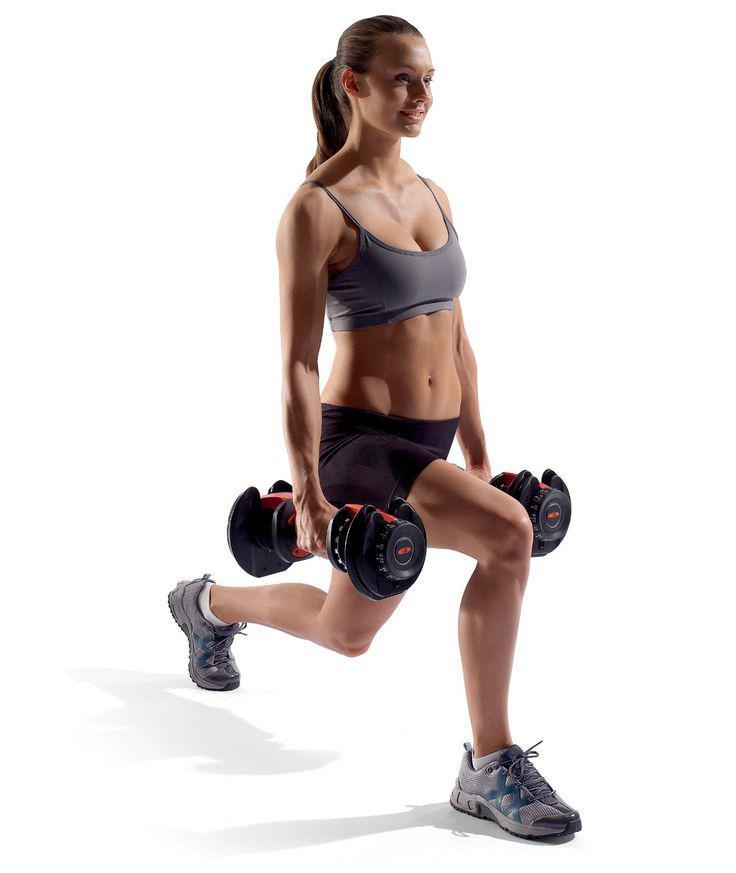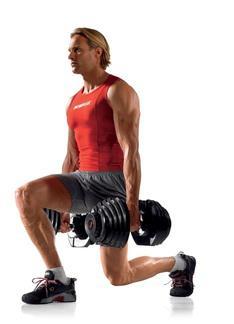The first image is the image on the left, the second image is the image on the right. Assess this claim about the two images: "A woman is in lunge position with weights down.". Correct or not? Answer yes or no. Yes. The first image is the image on the left, the second image is the image on the right. Evaluate the accuracy of this statement regarding the images: "An image shows a girl in sports bra and short black shorts doing a lunge without a mat while holding dumbbells.". Is it true? Answer yes or no. Yes. 